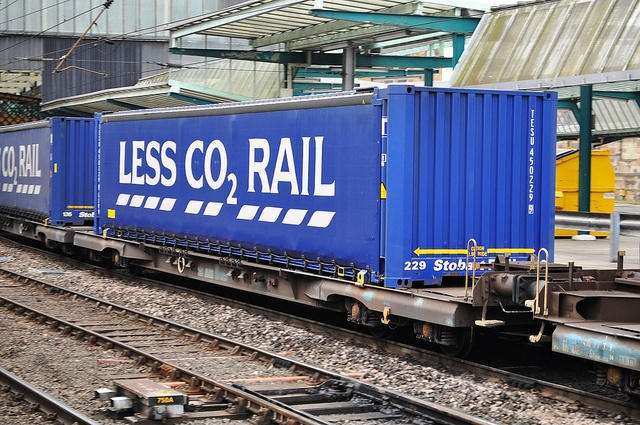Describe the objects in this image and their specific colors. I can see a train in gray, blue, and black tones in this image. 